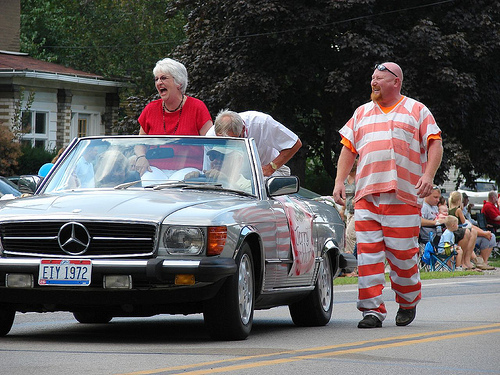<image>
Is there a man in the car? No. The man is not contained within the car. These objects have a different spatial relationship. Where is the man in relation to the car? Is it next to the car? Yes. The man is positioned adjacent to the car, located nearby in the same general area. 